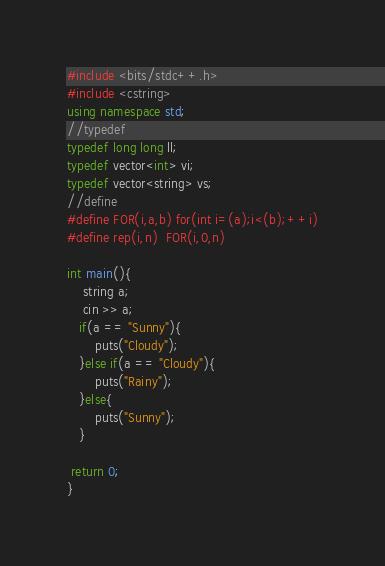<code> <loc_0><loc_0><loc_500><loc_500><_C++_>#include <bits/stdc++.h> 
#include <cstring>
using namespace std;
//typedef
typedef long long ll;
typedef vector<int> vi;
typedef vector<string> vs;
//define
#define FOR(i,a,b) for(int i=(a);i<(b);++i)
#define rep(i,n)  FOR(i,0,n)

int main(){
    string a;
    cin >> a;
   if(a == "Sunny"){
       puts("Cloudy");
   }else if(a == "Cloudy"){
       puts("Rainy");
   }else{
       puts("Sunny");
   }

 return 0;
}</code> 